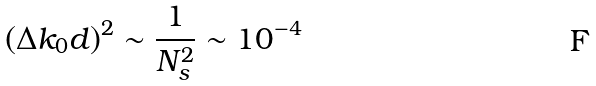Convert formula to latex. <formula><loc_0><loc_0><loc_500><loc_500>\left ( \Delta k _ { 0 } d \right ) ^ { 2 } \sim \frac { 1 } { N _ { s } ^ { 2 } } \sim 1 0 ^ { - 4 }</formula> 